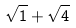Convert formula to latex. <formula><loc_0><loc_0><loc_500><loc_500>\sqrt { 1 } + \sqrt { 4 }</formula> 